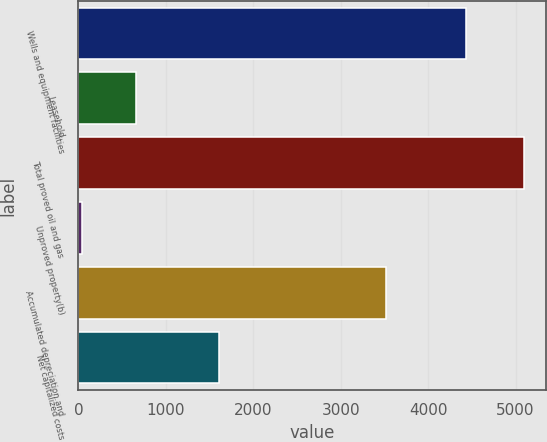<chart> <loc_0><loc_0><loc_500><loc_500><bar_chart><fcel>Wells and equipment facilities<fcel>Leasehold<fcel>Total proved oil and gas<fcel>Unproved property(b)<fcel>Accumulated depreciation and<fcel>Net capitalized costs<nl><fcel>4432<fcel>660<fcel>5092<fcel>38<fcel>3520<fcel>1610<nl></chart> 